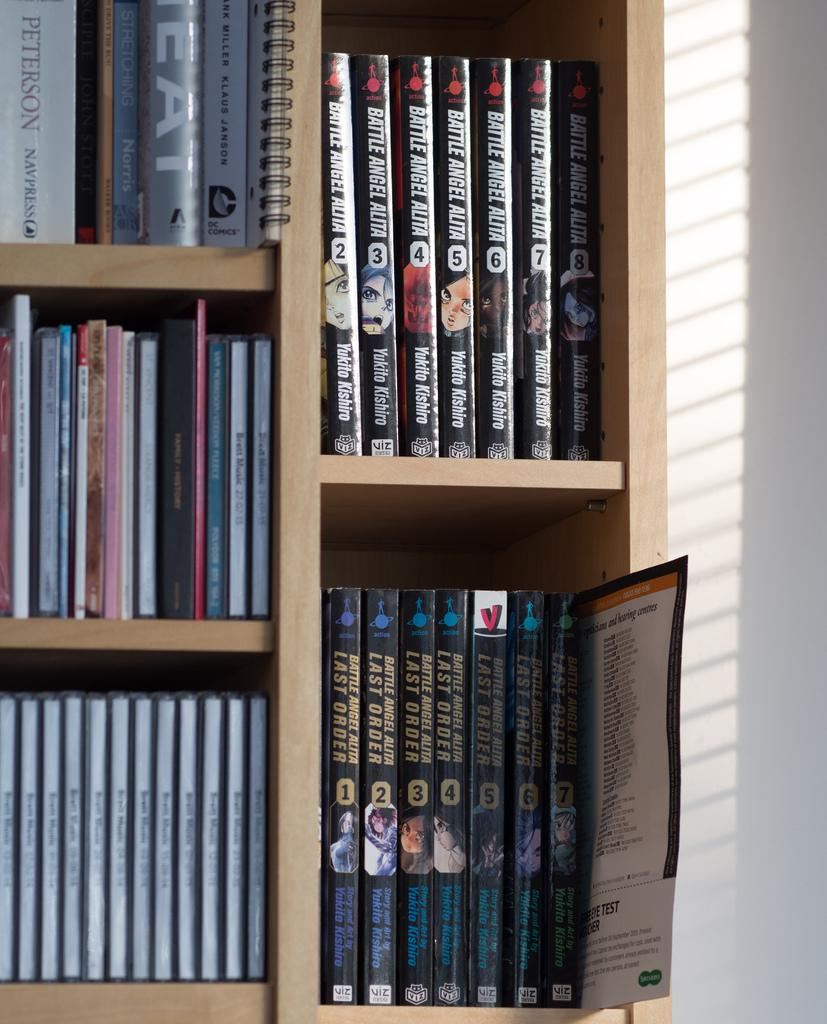<image>
Provide a brief description of the given image. A book shelf that has various titles including  a manga book series called battle angel alita 